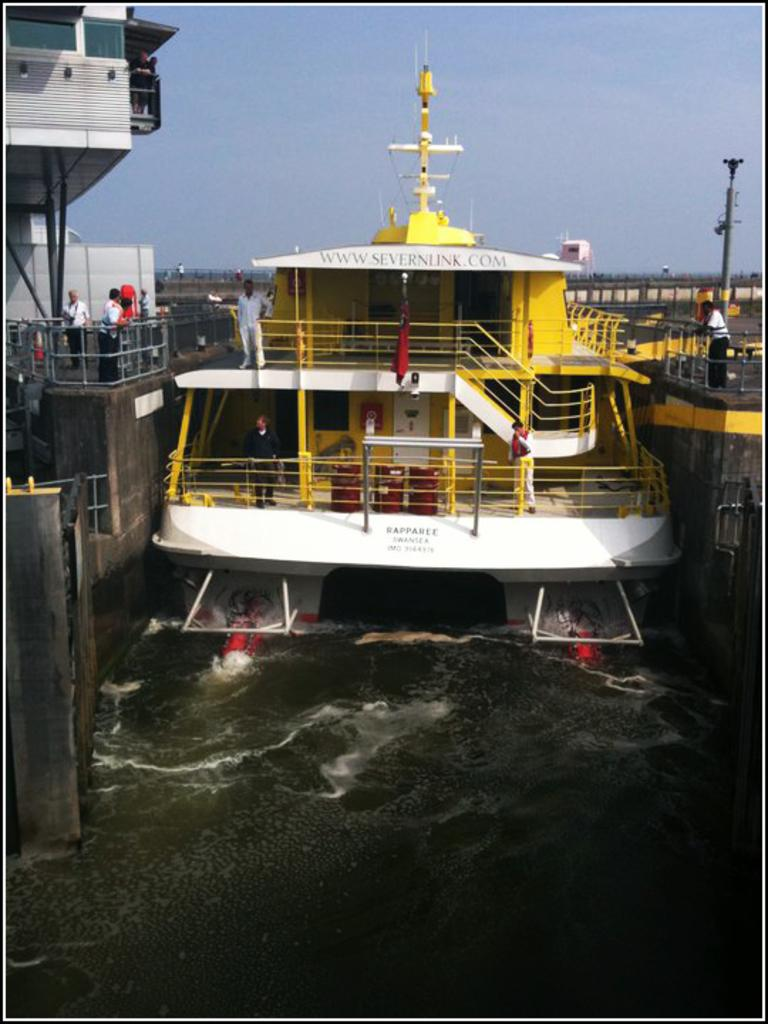What is the main subject of the image? The main subject of the image is a ship in the water. What else can be seen in the image besides the ship? There is a building visible in the image, and there are people standing near the building. What type of kite is being flown by the people near the building? There is no kite visible in the image; the people are standing near the building without any kites. What kind of hook is attached to the ship in the image? There is no hook visible on the ship in the image. 